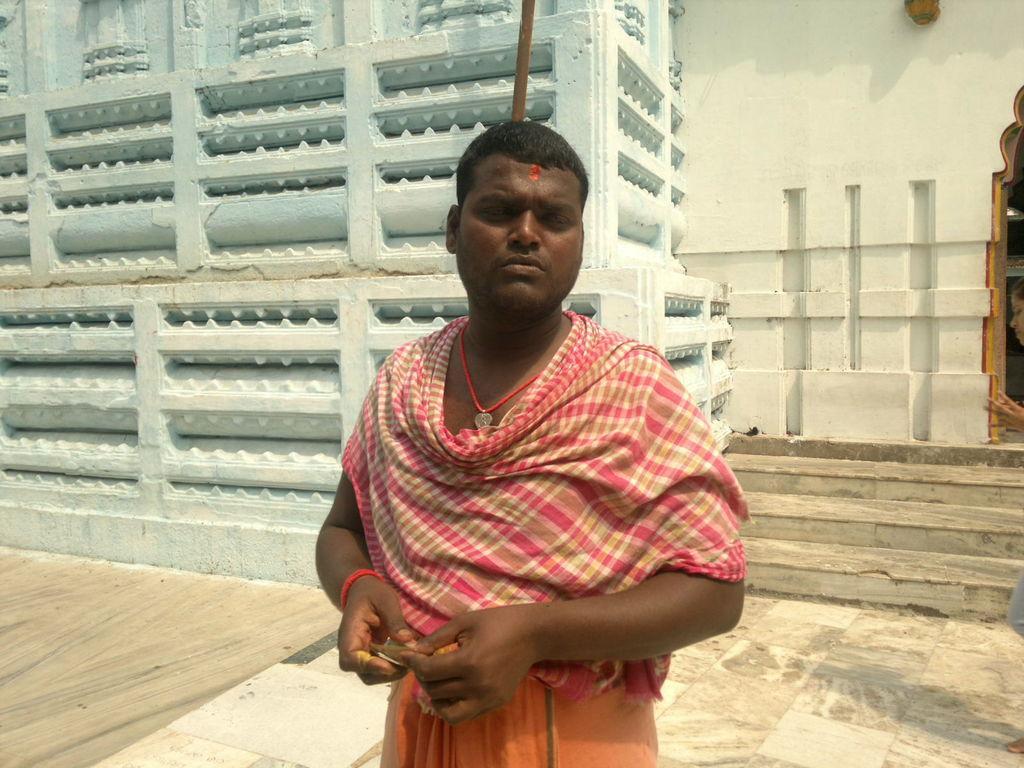Describe this image in one or two sentences. In this image we can see a person. In the background of the image there is a wall, steps and other objects. On the left side of the image there is a floor. On the right side of the image there is a floor and it looks like a person. 